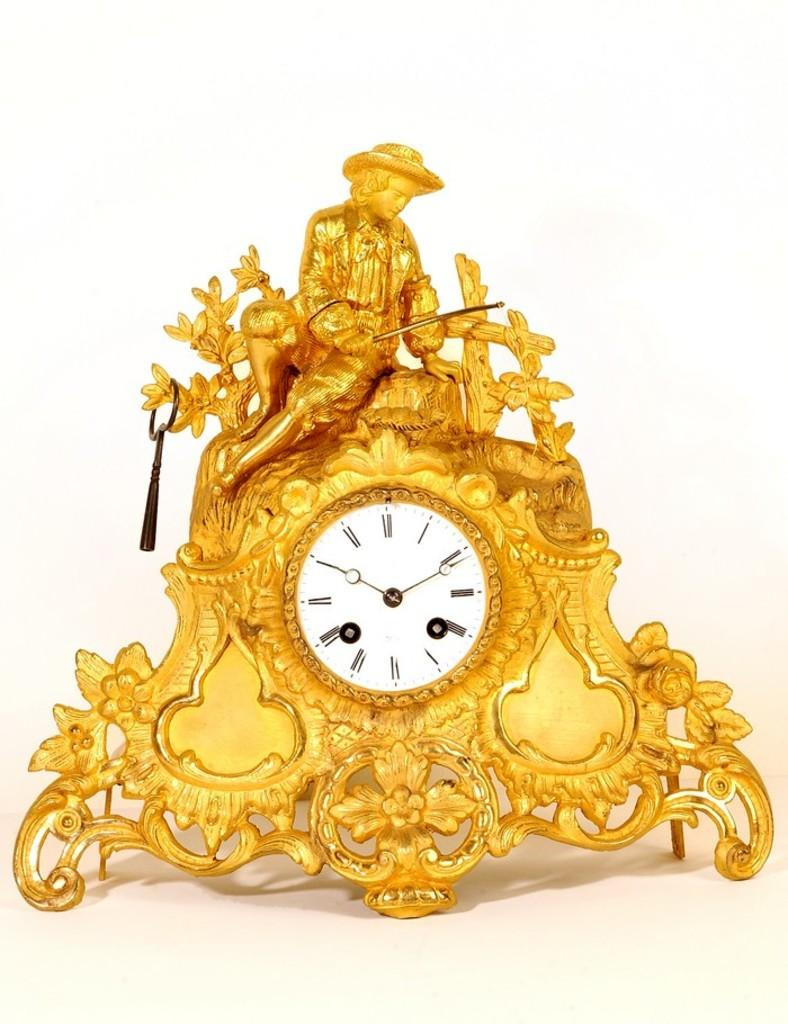Provide a one-sentence caption for the provided image. A golden clock with a fisherman on top reads the time as 2:50. 